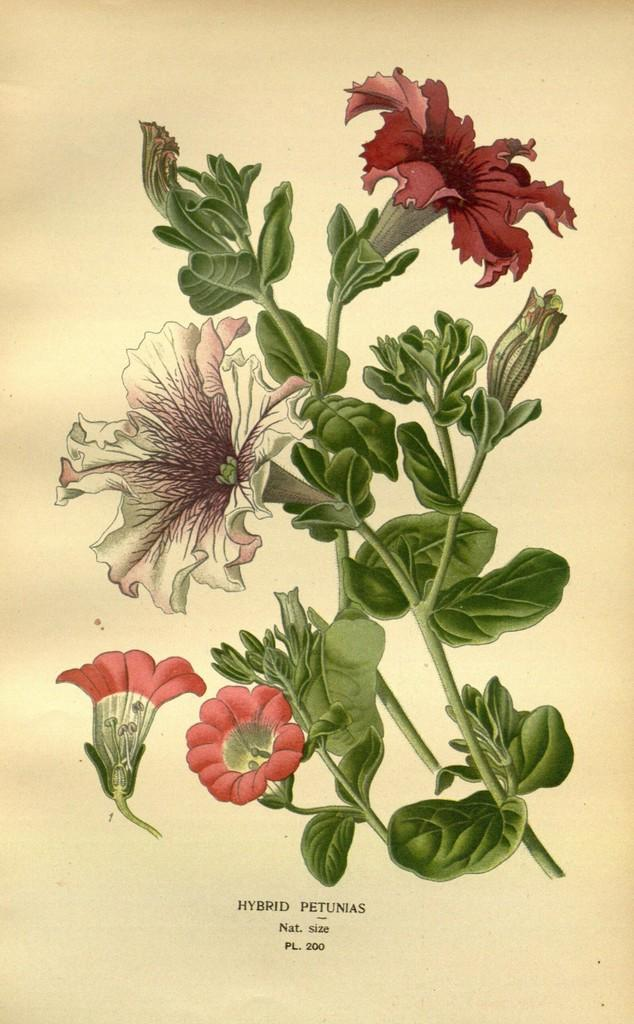What type of plant life is visible in the image? There are flowers and leaves in the image. Where are the flowers and leaves located in the image? The flowers and leaves are likely part of a plant or arrangement in the image. What is written at the bottom of the image? There is text at the bottom of the image. How does the sleet affect the leg of the person in the image? There is no person or sleet present in the image; it only features flowers, leaves, and text. 